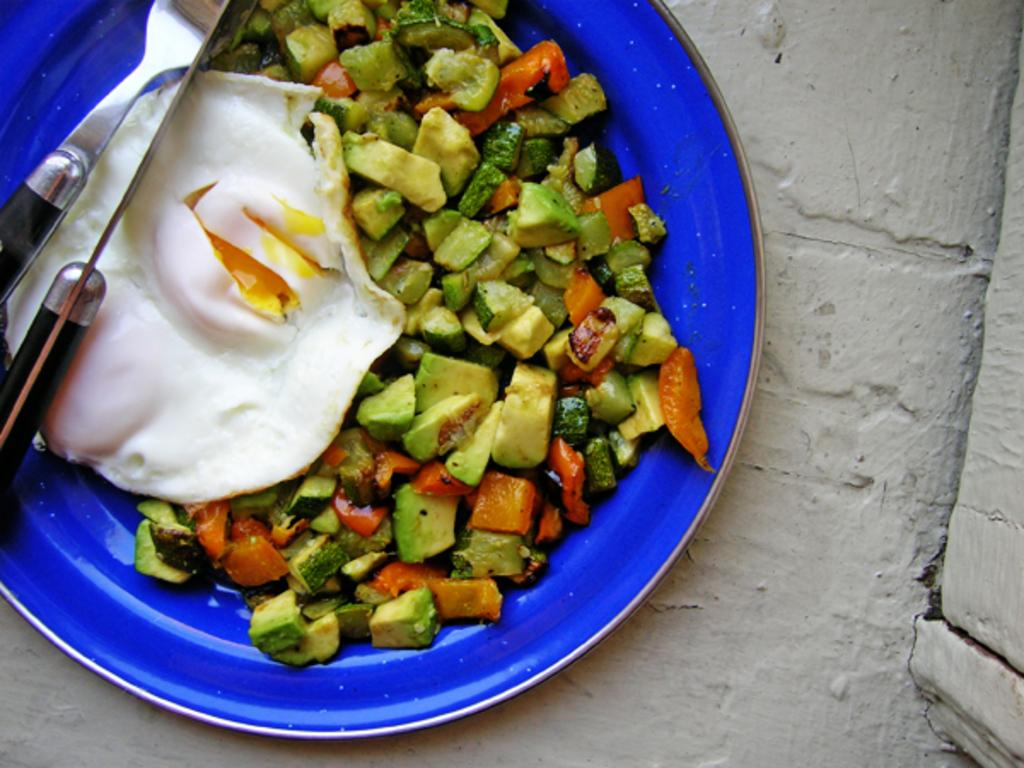What color is the plate in the image? The plate in the image is blue. Where is the plate located in the image? The plate is in the center of the image. What is on the plate? The plate contains food items, including an egg. What utensils are on the plate? There is a knife and a fork on the plate. What type of underwear is the writer wearing in the image? There is no writer or underwear present in the image. 